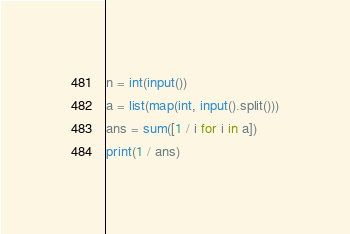<code> <loc_0><loc_0><loc_500><loc_500><_Python_>n = int(input())
a = list(map(int, input().split()))
ans = sum([1 / i for i in a])
print(1 / ans)
</code> 